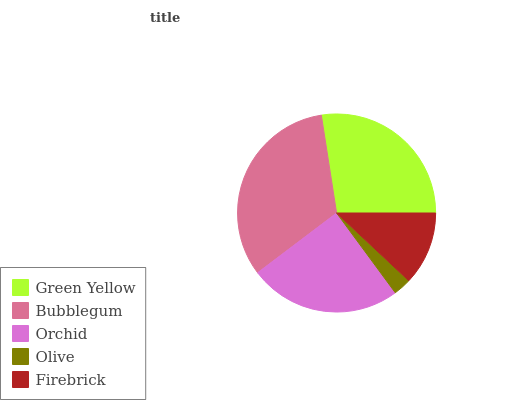Is Olive the minimum?
Answer yes or no. Yes. Is Bubblegum the maximum?
Answer yes or no. Yes. Is Orchid the minimum?
Answer yes or no. No. Is Orchid the maximum?
Answer yes or no. No. Is Bubblegum greater than Orchid?
Answer yes or no. Yes. Is Orchid less than Bubblegum?
Answer yes or no. Yes. Is Orchid greater than Bubblegum?
Answer yes or no. No. Is Bubblegum less than Orchid?
Answer yes or no. No. Is Orchid the high median?
Answer yes or no. Yes. Is Orchid the low median?
Answer yes or no. Yes. Is Green Yellow the high median?
Answer yes or no. No. Is Olive the low median?
Answer yes or no. No. 